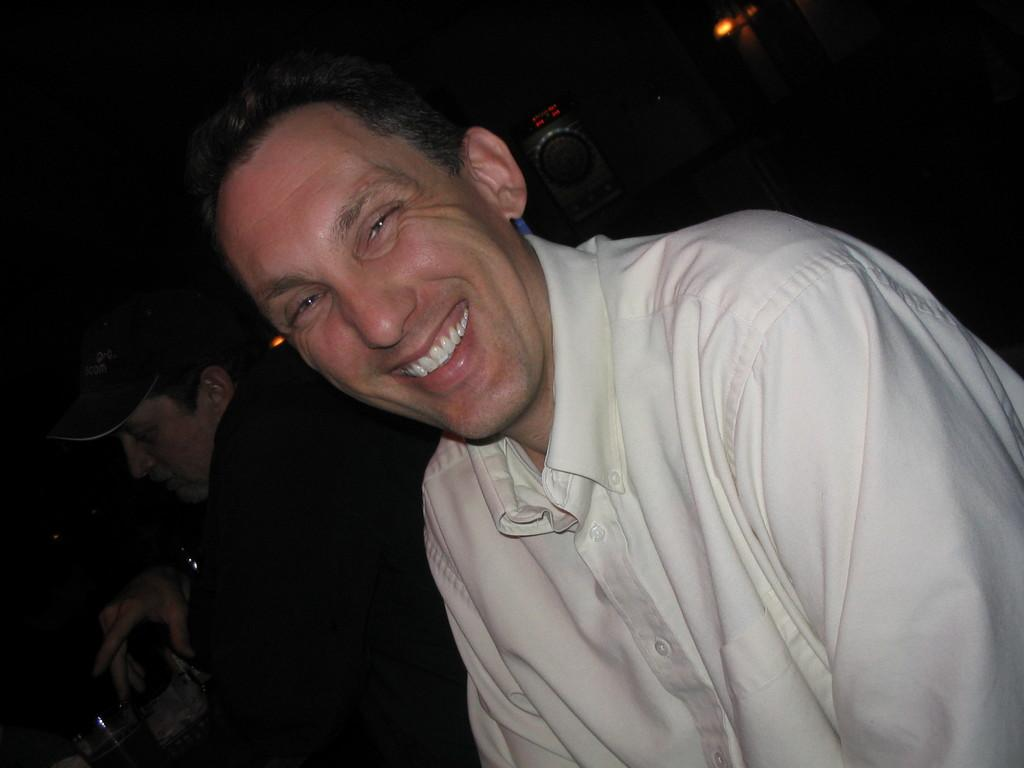How many people are in the image? There are two persons in the image. What can be seen in the bottom left corner of the image? There are glasses in the bottom left corner of the image. What is visible behind the two persons? There is an object and light visible behind the two persons. Can you describe the background of the image? The background of the image is dark. What type of bomb is being detonated in the image? There is no bomb present in the image. What kind of band is playing in the background of the image? There is no band present in the image. 